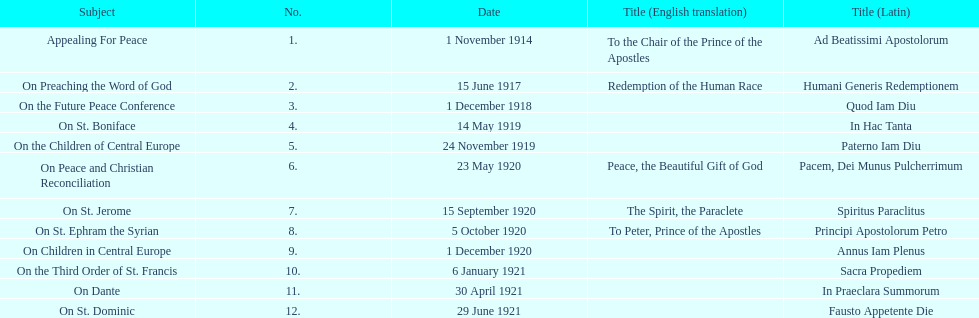After 1 december 1918 when was the next encyclical? 14 May 1919. 